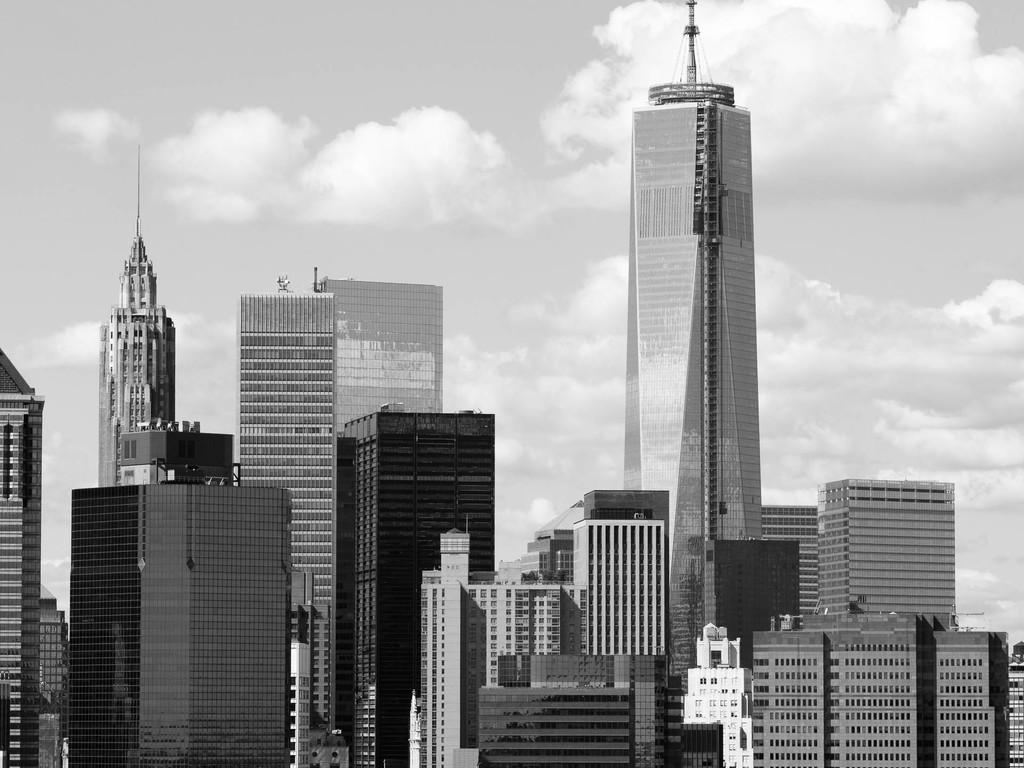What is the color scheme of the image? The image is black and white. What type of scene is depicted in the image? The image shows an outside view. What structures are visible in the foreground of the image? There are buildings in the foreground of the image. What can be seen in the background of the image? The sky is visible in the background of the image. What type of eggs can be seen in the image? There are no eggs present in the image. What substance is being used to spot clean the buildings in the image? There is no spot cleaning or substance visible in the image. 